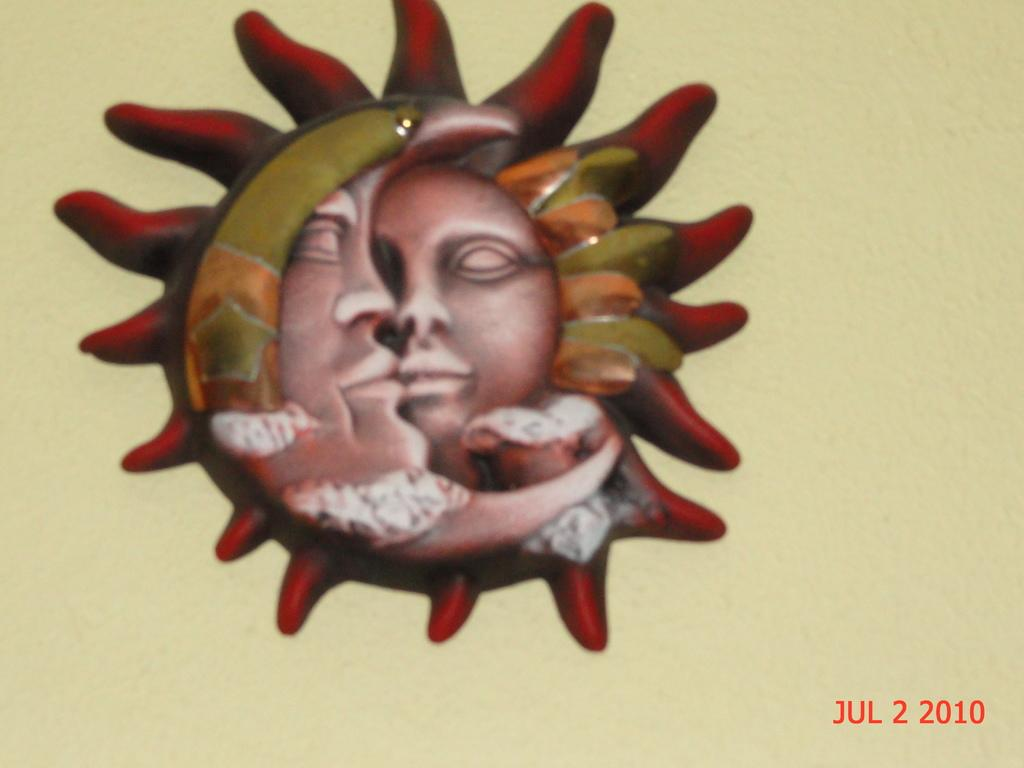What can be seen on the wall in the center of the image? There is a decoration on the wall in the center of the image. What is located at the bottom of the image? There is text at the bottom of the image. Where is the nest located in the image? There is no nest present in the image. How many lines can be seen in the image? The provided facts do not mention any lines in the image, so it is impossible to determine the number of lines. 